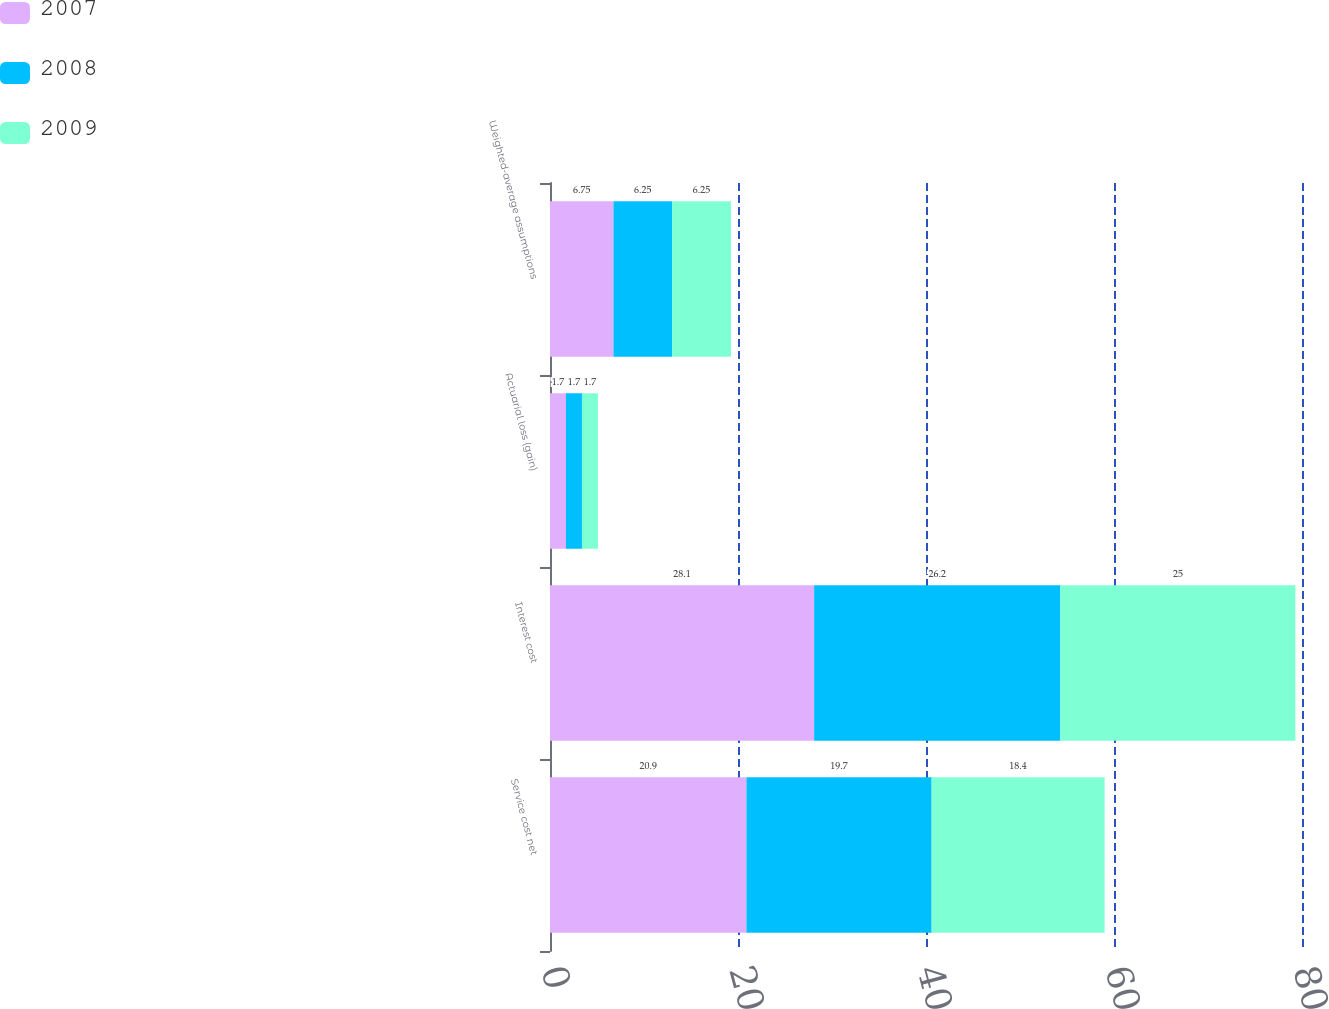Convert chart. <chart><loc_0><loc_0><loc_500><loc_500><stacked_bar_chart><ecel><fcel>Service cost net<fcel>Interest cost<fcel>Actuarial loss (gain)<fcel>Weighted-average assumptions<nl><fcel>2007<fcel>20.9<fcel>28.1<fcel>1.7<fcel>6.75<nl><fcel>2008<fcel>19.7<fcel>26.2<fcel>1.7<fcel>6.25<nl><fcel>2009<fcel>18.4<fcel>25<fcel>1.7<fcel>6.25<nl></chart> 